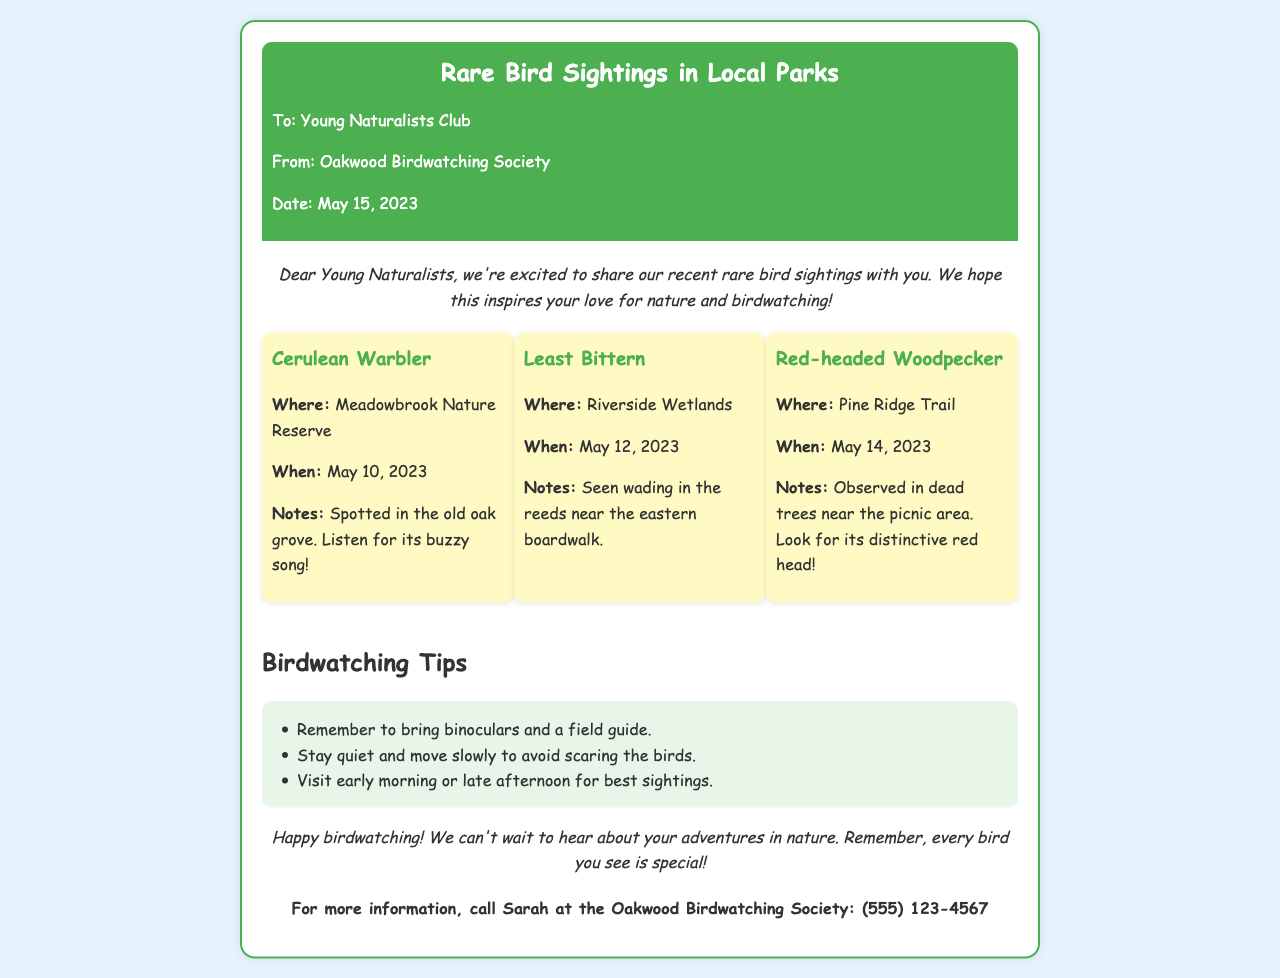What is the date of the fax? The date of the fax is indicated in the header section of the document.
Answer: May 15, 2023 Who sent the fax? The sender's information is listed in the header of the document.
Answer: Oakwood Birdwatching Society What is one of the rare birds mentioned? The document lists specific rare bird sightings, which can be found in the sightings section.
Answer: Cerulean Warbler Where was the Least Bittern spotted? The location of the Least Bittern sighting is mentioned in its respective sighting entry.
Answer: Riverside Wetlands What should you remember to bring while birdwatching? The document contains tips for birdwatching that specify necessary items to bring.
Answer: Binoculars Why is it recommended to visit in the early morning or late afternoon? This information is part of the birdwatching tips explaining the best times for sightings.
Answer: Best sightings What is the main purpose of the fax? The introduction of the document outlines the main intent behind sending the fax.
Answer: To share rare bird sightings What special feature is the Red-headed Woodpecker known for? The distinctive features of the Red-headed Woodpecker are noted in its sighting description.
Answer: Distinctive red head Who can you call for more information? The contact information at the end of the document includes a person's name and a phone number.
Answer: Sarah 